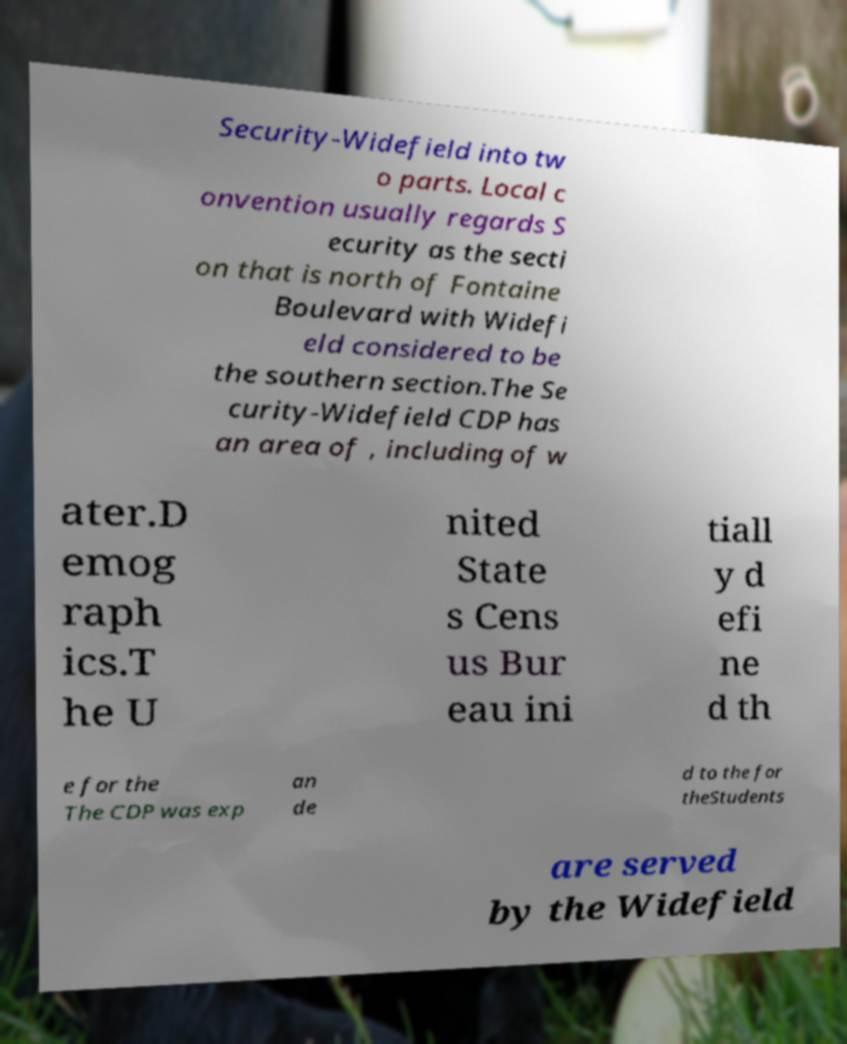Please identify and transcribe the text found in this image. Security-Widefield into tw o parts. Local c onvention usually regards S ecurity as the secti on that is north of Fontaine Boulevard with Widefi eld considered to be the southern section.The Se curity-Widefield CDP has an area of , including of w ater.D emog raph ics.T he U nited State s Cens us Bur eau ini tiall y d efi ne d th e for the The CDP was exp an de d to the for theStudents are served by the Widefield 